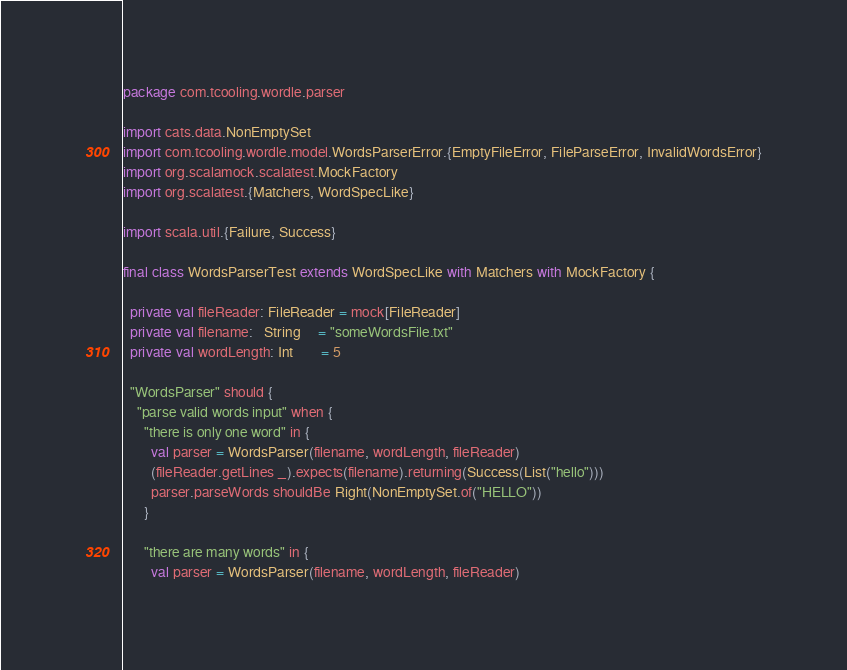Convert code to text. <code><loc_0><loc_0><loc_500><loc_500><_Scala_>package com.tcooling.wordle.parser

import cats.data.NonEmptySet
import com.tcooling.wordle.model.WordsParserError.{EmptyFileError, FileParseError, InvalidWordsError}
import org.scalamock.scalatest.MockFactory
import org.scalatest.{Matchers, WordSpecLike}

import scala.util.{Failure, Success}

final class WordsParserTest extends WordSpecLike with Matchers with MockFactory {

  private val fileReader: FileReader = mock[FileReader]
  private val filename:   String     = "someWordsFile.txt"
  private val wordLength: Int        = 5

  "WordsParser" should {
    "parse valid words input" when {
      "there is only one word" in {
        val parser = WordsParser(filename, wordLength, fileReader)
        (fileReader.getLines _).expects(filename).returning(Success(List("hello")))
        parser.parseWords shouldBe Right(NonEmptySet.of("HELLO"))
      }

      "there are many words" in {
        val parser = WordsParser(filename, wordLength, fileReader)</code> 